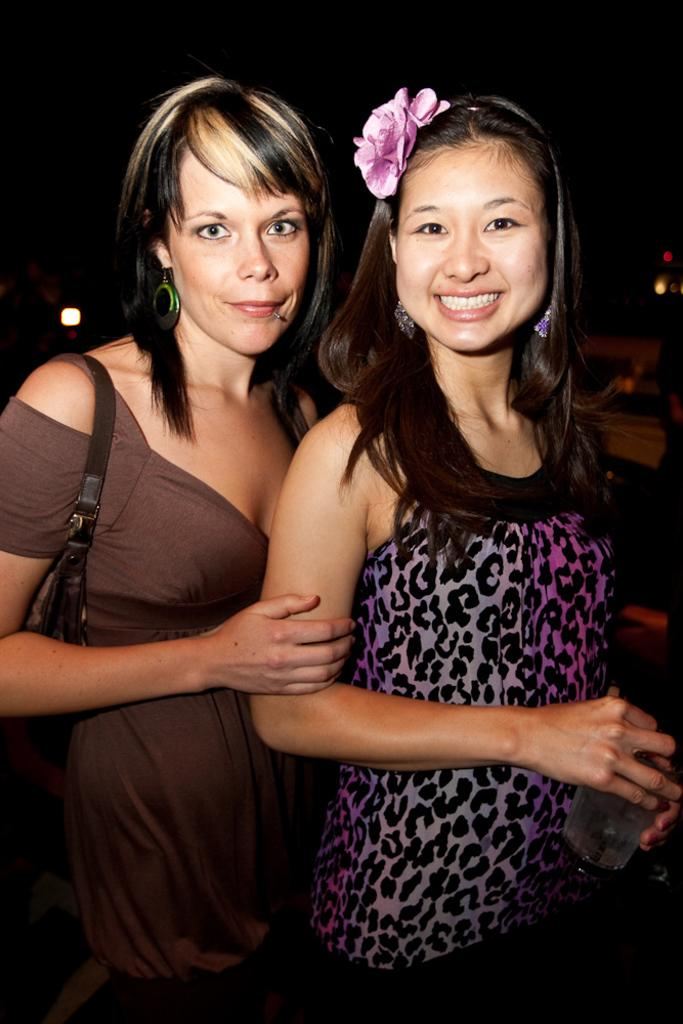How many women are in the image? There are two women standing in the image. What is the woman on the right holding? The woman on the right is holding a glass. What accessory is the woman on the left wearing? The woman on the left is wearing a handbag. What can be observed about the background of the image? The background of the image is dark. What flavor of ice cream are the women enjoying in the image? There is no ice cream present in the image, so it is not possible to determine the flavor. 